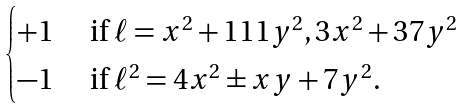Convert formula to latex. <formula><loc_0><loc_0><loc_500><loc_500>\begin{cases} + 1 & \text { if } \ell = x ^ { 2 } + 1 1 1 y ^ { 2 } , 3 x ^ { 2 } + 3 7 y ^ { 2 } \\ - 1 & \text { if } \ell ^ { 2 } = 4 x ^ { 2 } \pm x y + 7 y ^ { 2 } . \end{cases}</formula> 